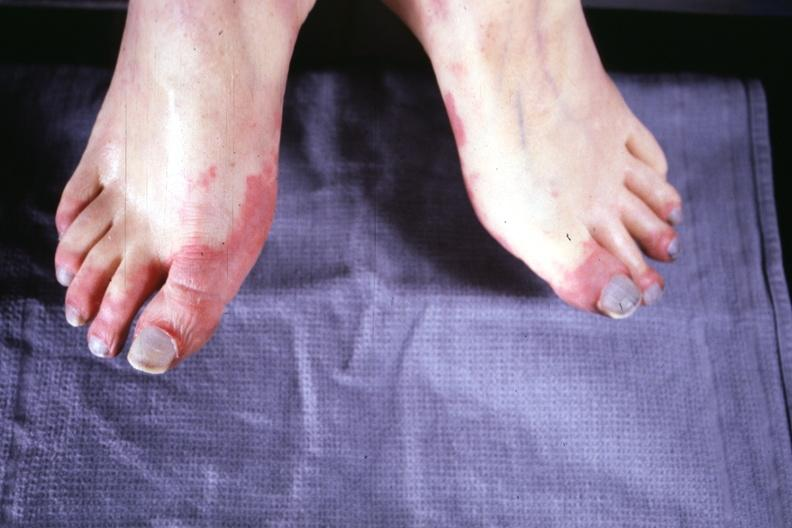s cytomegaly present?
Answer the question using a single word or phrase. No 